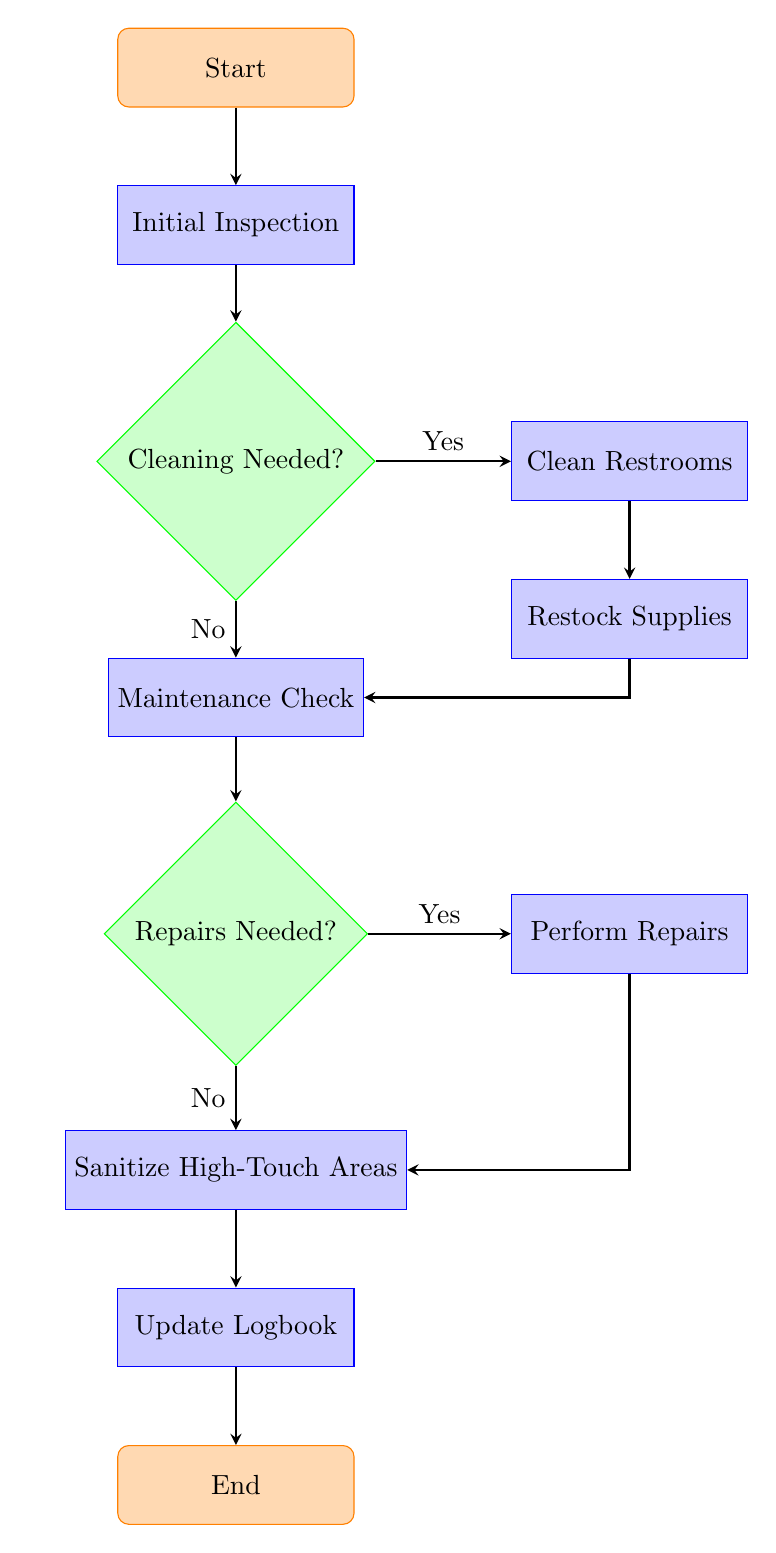What is the initial action in the process? The diagram starts with the "Start" node, which is followed by the "Initial Inspection" node. Therefore, the first action in the facility maintenance process is to perform the initial inspection.
Answer: Initial Inspection How many decision nodes are present in the diagram? The diagram features two decision nodes: "Cleaning Needed?" and "Repairs Needed?". Thus, there are a total of two decision nodes.
Answer: 2 What happens if cleaning is not needed? If cleaning is not needed, the diagram indicates that the process leads to a "Maintenance Check" after the "Cleaning Needed?" decision node, which clearly states "No" for cleaning.
Answer: Maintenance Check What is the next step after "Restock Supplies"? Following "Restock Supplies", the diagram indicates that the next step is to perform a "Maintenance Check". This is a direct connection from one process to another in the flow.
Answer: Maintenance Check If repairs are needed, what is the next action? If repairs are needed, the flow indicates that the process moves to "Perform Repairs" after the "Repairs Needed?" decision node indicates "Yes". Therefore, the next action is to perform repairs.
Answer: Perform Repairs What is the final step before the process ends? The final step before the process reaches the "End" is to "Update Logbook". The order is established through the flow of actions leading to completion.
Answer: Update Logbook How does the process flow from "Perform Repairs"? From "Perform Repairs", the flow chart shows that the next step is to "Sanitize High-Touch Areas". This connection indicates a sequential process intending to ensure cleanliness after repairs.
Answer: Sanitize High-Touch Areas What is the relationship between the "Cleaning Needed?" decision node and "Clean Restrooms"? The relationship is that if the answer to "Cleaning Needed?" is "Yes", the process transitions to "Clean Restrooms", indicating conditional logic based on the initial inspection.
Answer: Yes What action is taken after "Sanitize High-Touch Areas"? The action taken after "Sanitize High-Touch Areas" is to "Update Logbook", which signifies the documentation step in the maintenance process.
Answer: Update Logbook 